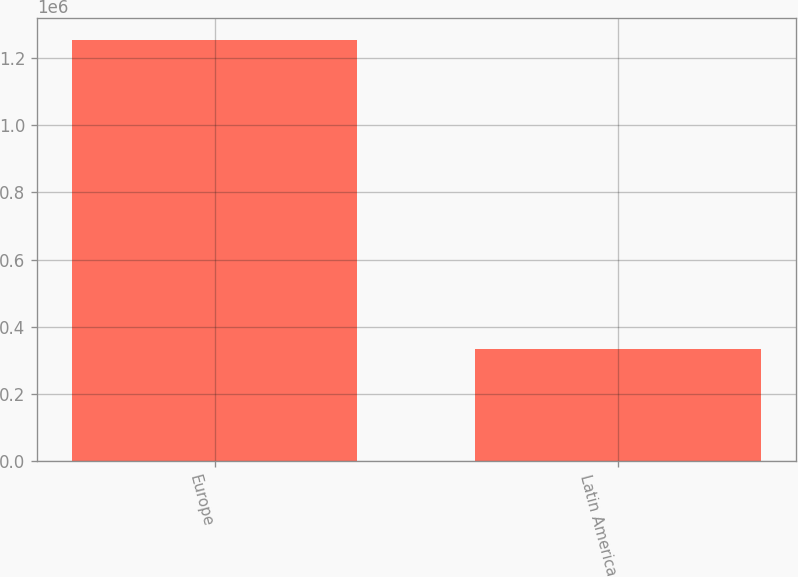<chart> <loc_0><loc_0><loc_500><loc_500><bar_chart><fcel>Europe<fcel>Latin America<nl><fcel>1.25443e+06<fcel>334887<nl></chart> 